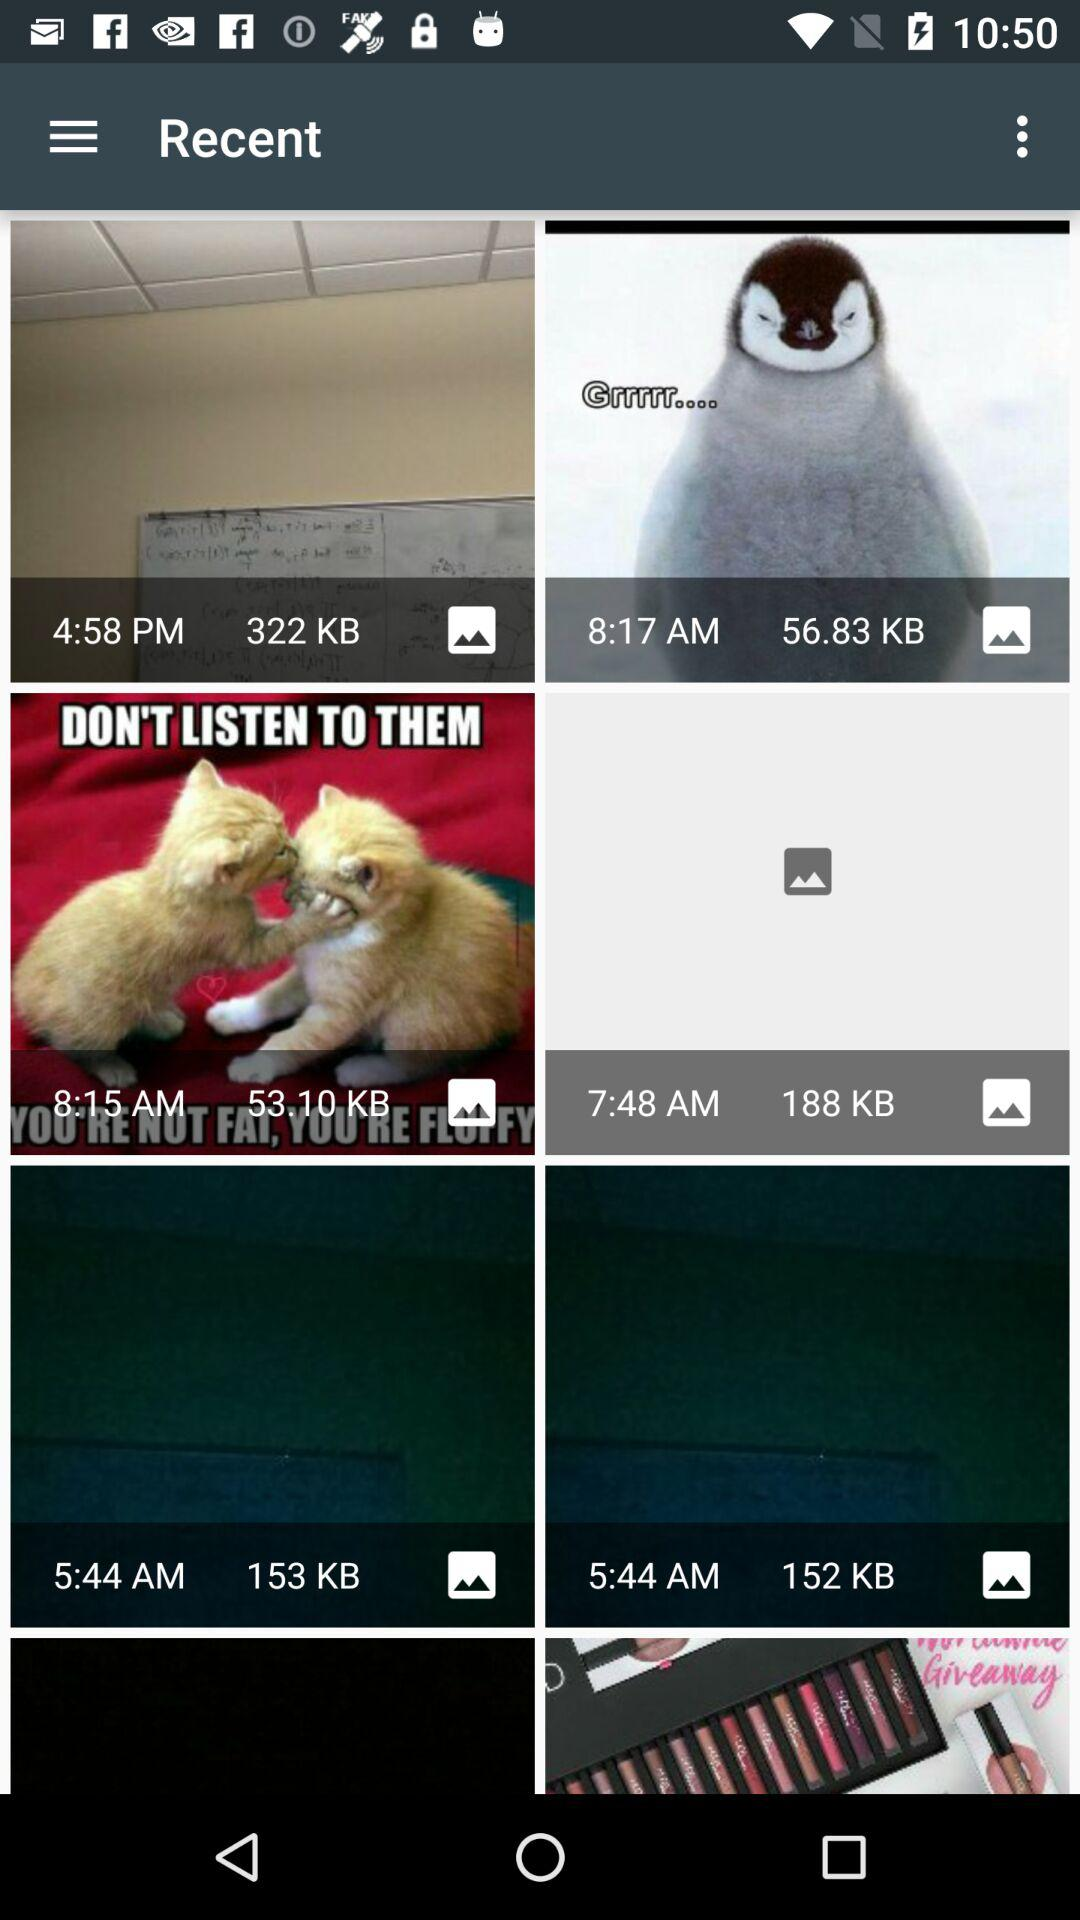Which file has the lowest file size?
When the provided information is insufficient, respond with <no answer>. <no answer> 